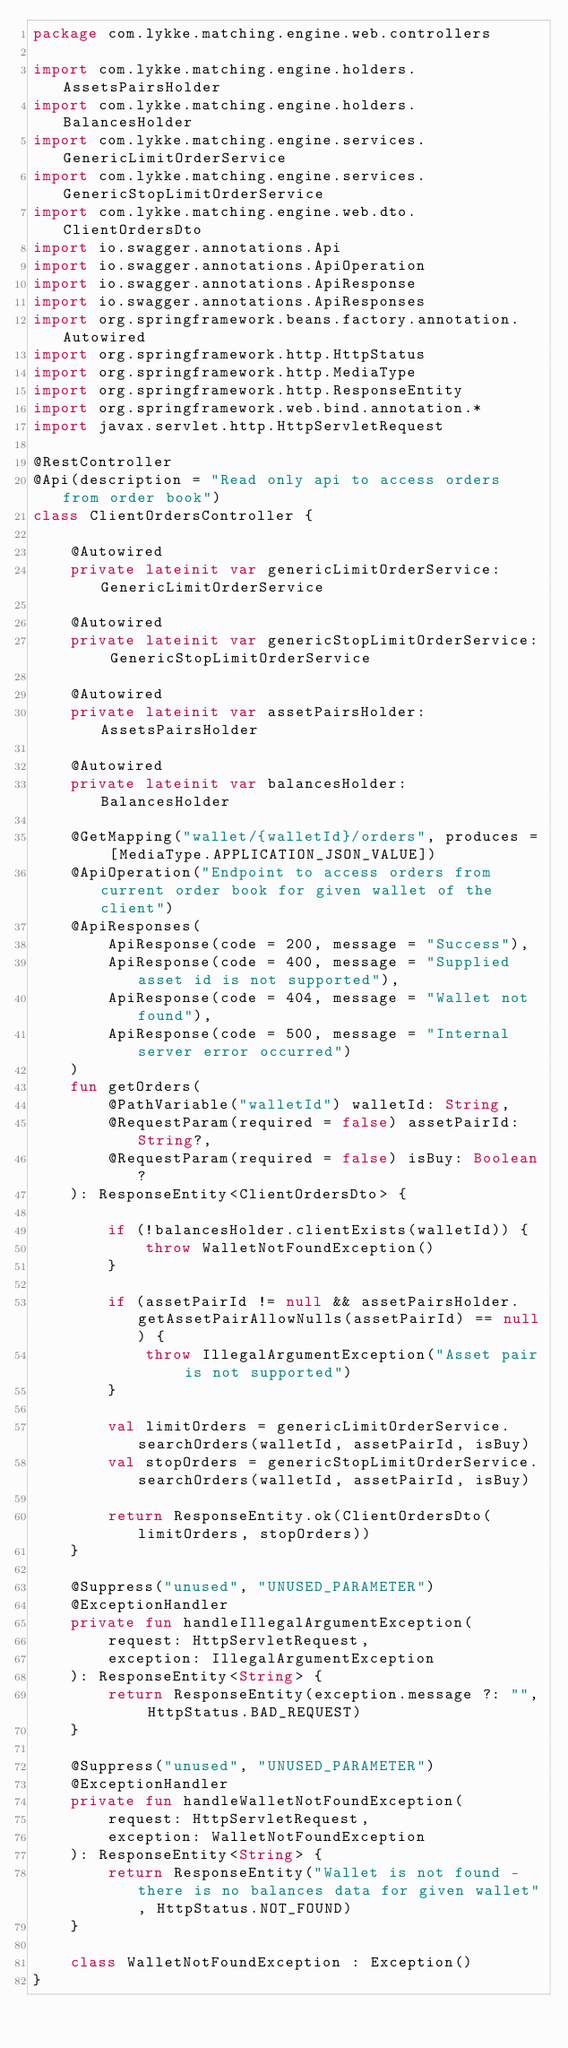Convert code to text. <code><loc_0><loc_0><loc_500><loc_500><_Kotlin_>package com.lykke.matching.engine.web.controllers

import com.lykke.matching.engine.holders.AssetsPairsHolder
import com.lykke.matching.engine.holders.BalancesHolder
import com.lykke.matching.engine.services.GenericLimitOrderService
import com.lykke.matching.engine.services.GenericStopLimitOrderService
import com.lykke.matching.engine.web.dto.ClientOrdersDto
import io.swagger.annotations.Api
import io.swagger.annotations.ApiOperation
import io.swagger.annotations.ApiResponse
import io.swagger.annotations.ApiResponses
import org.springframework.beans.factory.annotation.Autowired
import org.springframework.http.HttpStatus
import org.springframework.http.MediaType
import org.springframework.http.ResponseEntity
import org.springframework.web.bind.annotation.*
import javax.servlet.http.HttpServletRequest

@RestController
@Api(description = "Read only api to access orders from order book")
class ClientOrdersController {

    @Autowired
    private lateinit var genericLimitOrderService: GenericLimitOrderService

    @Autowired
    private lateinit var genericStopLimitOrderService: GenericStopLimitOrderService

    @Autowired
    private lateinit var assetPairsHolder: AssetsPairsHolder

    @Autowired
    private lateinit var balancesHolder: BalancesHolder

    @GetMapping("wallet/{walletId}/orders", produces = [MediaType.APPLICATION_JSON_VALUE])
    @ApiOperation("Endpoint to access orders from current order book for given wallet of the client")
    @ApiResponses(
        ApiResponse(code = 200, message = "Success"),
        ApiResponse(code = 400, message = "Supplied asset id is not supported"),
        ApiResponse(code = 404, message = "Wallet not found"),
        ApiResponse(code = 500, message = "Internal server error occurred")
    )
    fun getOrders(
        @PathVariable("walletId") walletId: String,
        @RequestParam(required = false) assetPairId: String?,
        @RequestParam(required = false) isBuy: Boolean?
    ): ResponseEntity<ClientOrdersDto> {

        if (!balancesHolder.clientExists(walletId)) {
            throw WalletNotFoundException()
        }

        if (assetPairId != null && assetPairsHolder.getAssetPairAllowNulls(assetPairId) == null) {
            throw IllegalArgumentException("Asset pair is not supported")
        }

        val limitOrders = genericLimitOrderService.searchOrders(walletId, assetPairId, isBuy)
        val stopOrders = genericStopLimitOrderService.searchOrders(walletId, assetPairId, isBuy)

        return ResponseEntity.ok(ClientOrdersDto(limitOrders, stopOrders))
    }

    @Suppress("unused", "UNUSED_PARAMETER")
    @ExceptionHandler
    private fun handleIllegalArgumentException(
        request: HttpServletRequest,
        exception: IllegalArgumentException
    ): ResponseEntity<String> {
        return ResponseEntity(exception.message ?: "", HttpStatus.BAD_REQUEST)
    }

    @Suppress("unused", "UNUSED_PARAMETER")
    @ExceptionHandler
    private fun handleWalletNotFoundException(
        request: HttpServletRequest,
        exception: WalletNotFoundException
    ): ResponseEntity<String> {
        return ResponseEntity("Wallet is not found - there is no balances data for given wallet", HttpStatus.NOT_FOUND)
    }

    class WalletNotFoundException : Exception()
}</code> 